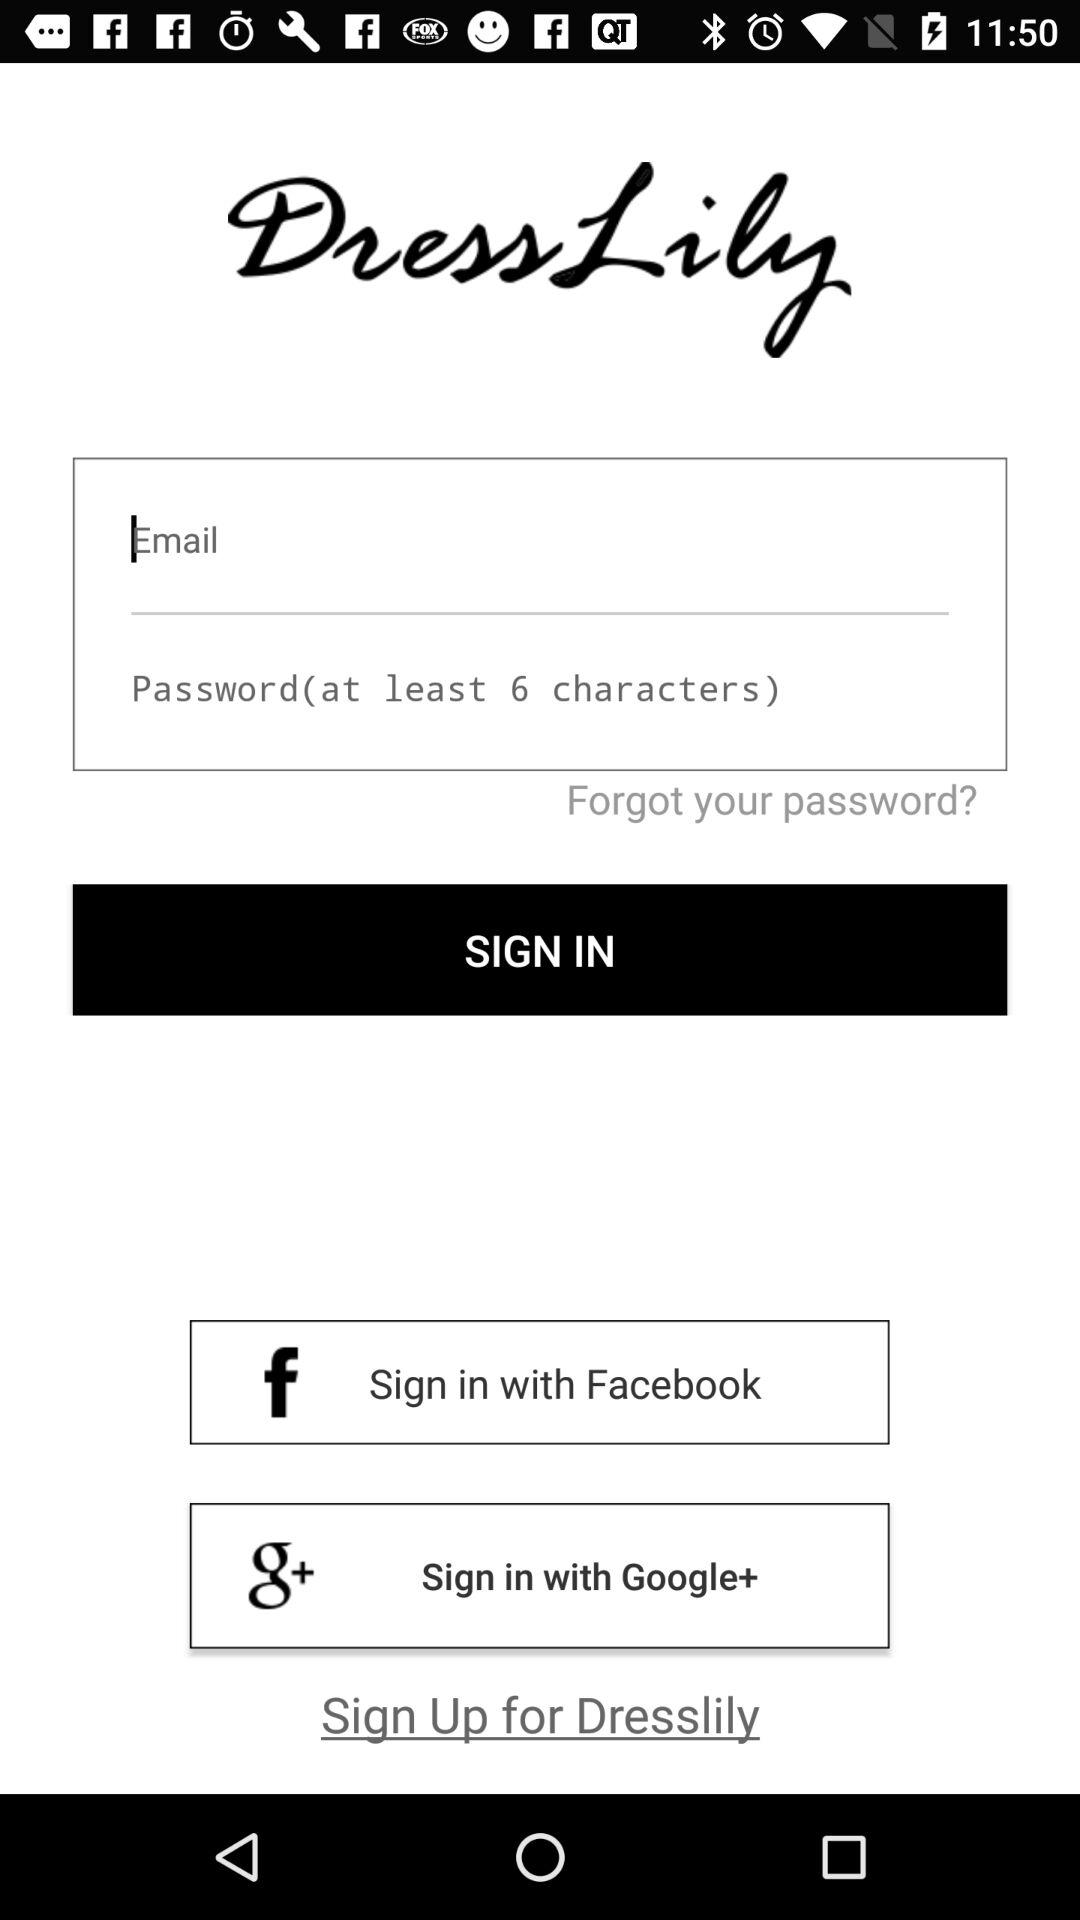What is the application name? The application name is "DressLily". 